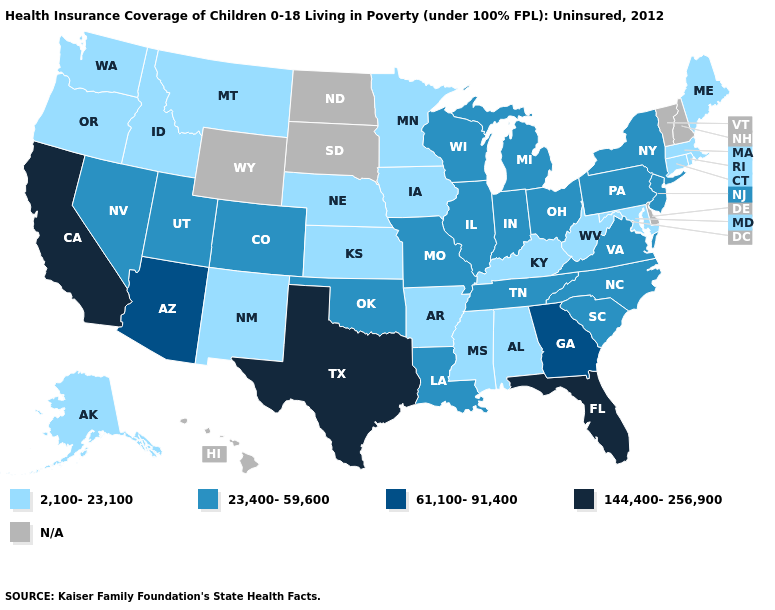How many symbols are there in the legend?
Answer briefly. 5. What is the value of Massachusetts?
Keep it brief. 2,100-23,100. Name the states that have a value in the range 2,100-23,100?
Concise answer only. Alabama, Alaska, Arkansas, Connecticut, Idaho, Iowa, Kansas, Kentucky, Maine, Maryland, Massachusetts, Minnesota, Mississippi, Montana, Nebraska, New Mexico, Oregon, Rhode Island, Washington, West Virginia. What is the value of Connecticut?
Be succinct. 2,100-23,100. Among the states that border Tennessee , does Georgia have the highest value?
Be succinct. Yes. What is the lowest value in the USA?
Give a very brief answer. 2,100-23,100. Does Kansas have the highest value in the MidWest?
Answer briefly. No. What is the value of Hawaii?
Answer briefly. N/A. Does Connecticut have the lowest value in the USA?
Be succinct. Yes. Name the states that have a value in the range 61,100-91,400?
Answer briefly. Arizona, Georgia. How many symbols are there in the legend?
Concise answer only. 5. 